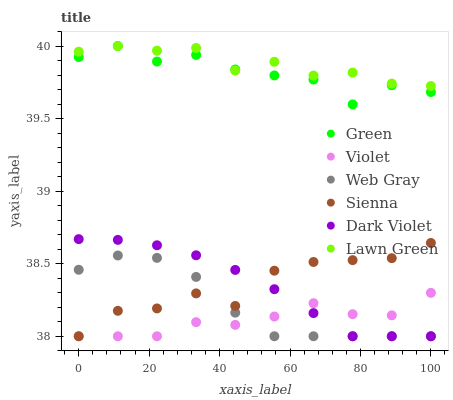Does Violet have the minimum area under the curve?
Answer yes or no. Yes. Does Lawn Green have the maximum area under the curve?
Answer yes or no. Yes. Does Web Gray have the minimum area under the curve?
Answer yes or no. No. Does Web Gray have the maximum area under the curve?
Answer yes or no. No. Is Dark Violet the smoothest?
Answer yes or no. Yes. Is Green the roughest?
Answer yes or no. Yes. Is Web Gray the smoothest?
Answer yes or no. No. Is Web Gray the roughest?
Answer yes or no. No. Does Web Gray have the lowest value?
Answer yes or no. Yes. Does Green have the lowest value?
Answer yes or no. No. Does Green have the highest value?
Answer yes or no. Yes. Does Web Gray have the highest value?
Answer yes or no. No. Is Web Gray less than Green?
Answer yes or no. Yes. Is Green greater than Violet?
Answer yes or no. Yes. Does Web Gray intersect Dark Violet?
Answer yes or no. Yes. Is Web Gray less than Dark Violet?
Answer yes or no. No. Is Web Gray greater than Dark Violet?
Answer yes or no. No. Does Web Gray intersect Green?
Answer yes or no. No. 